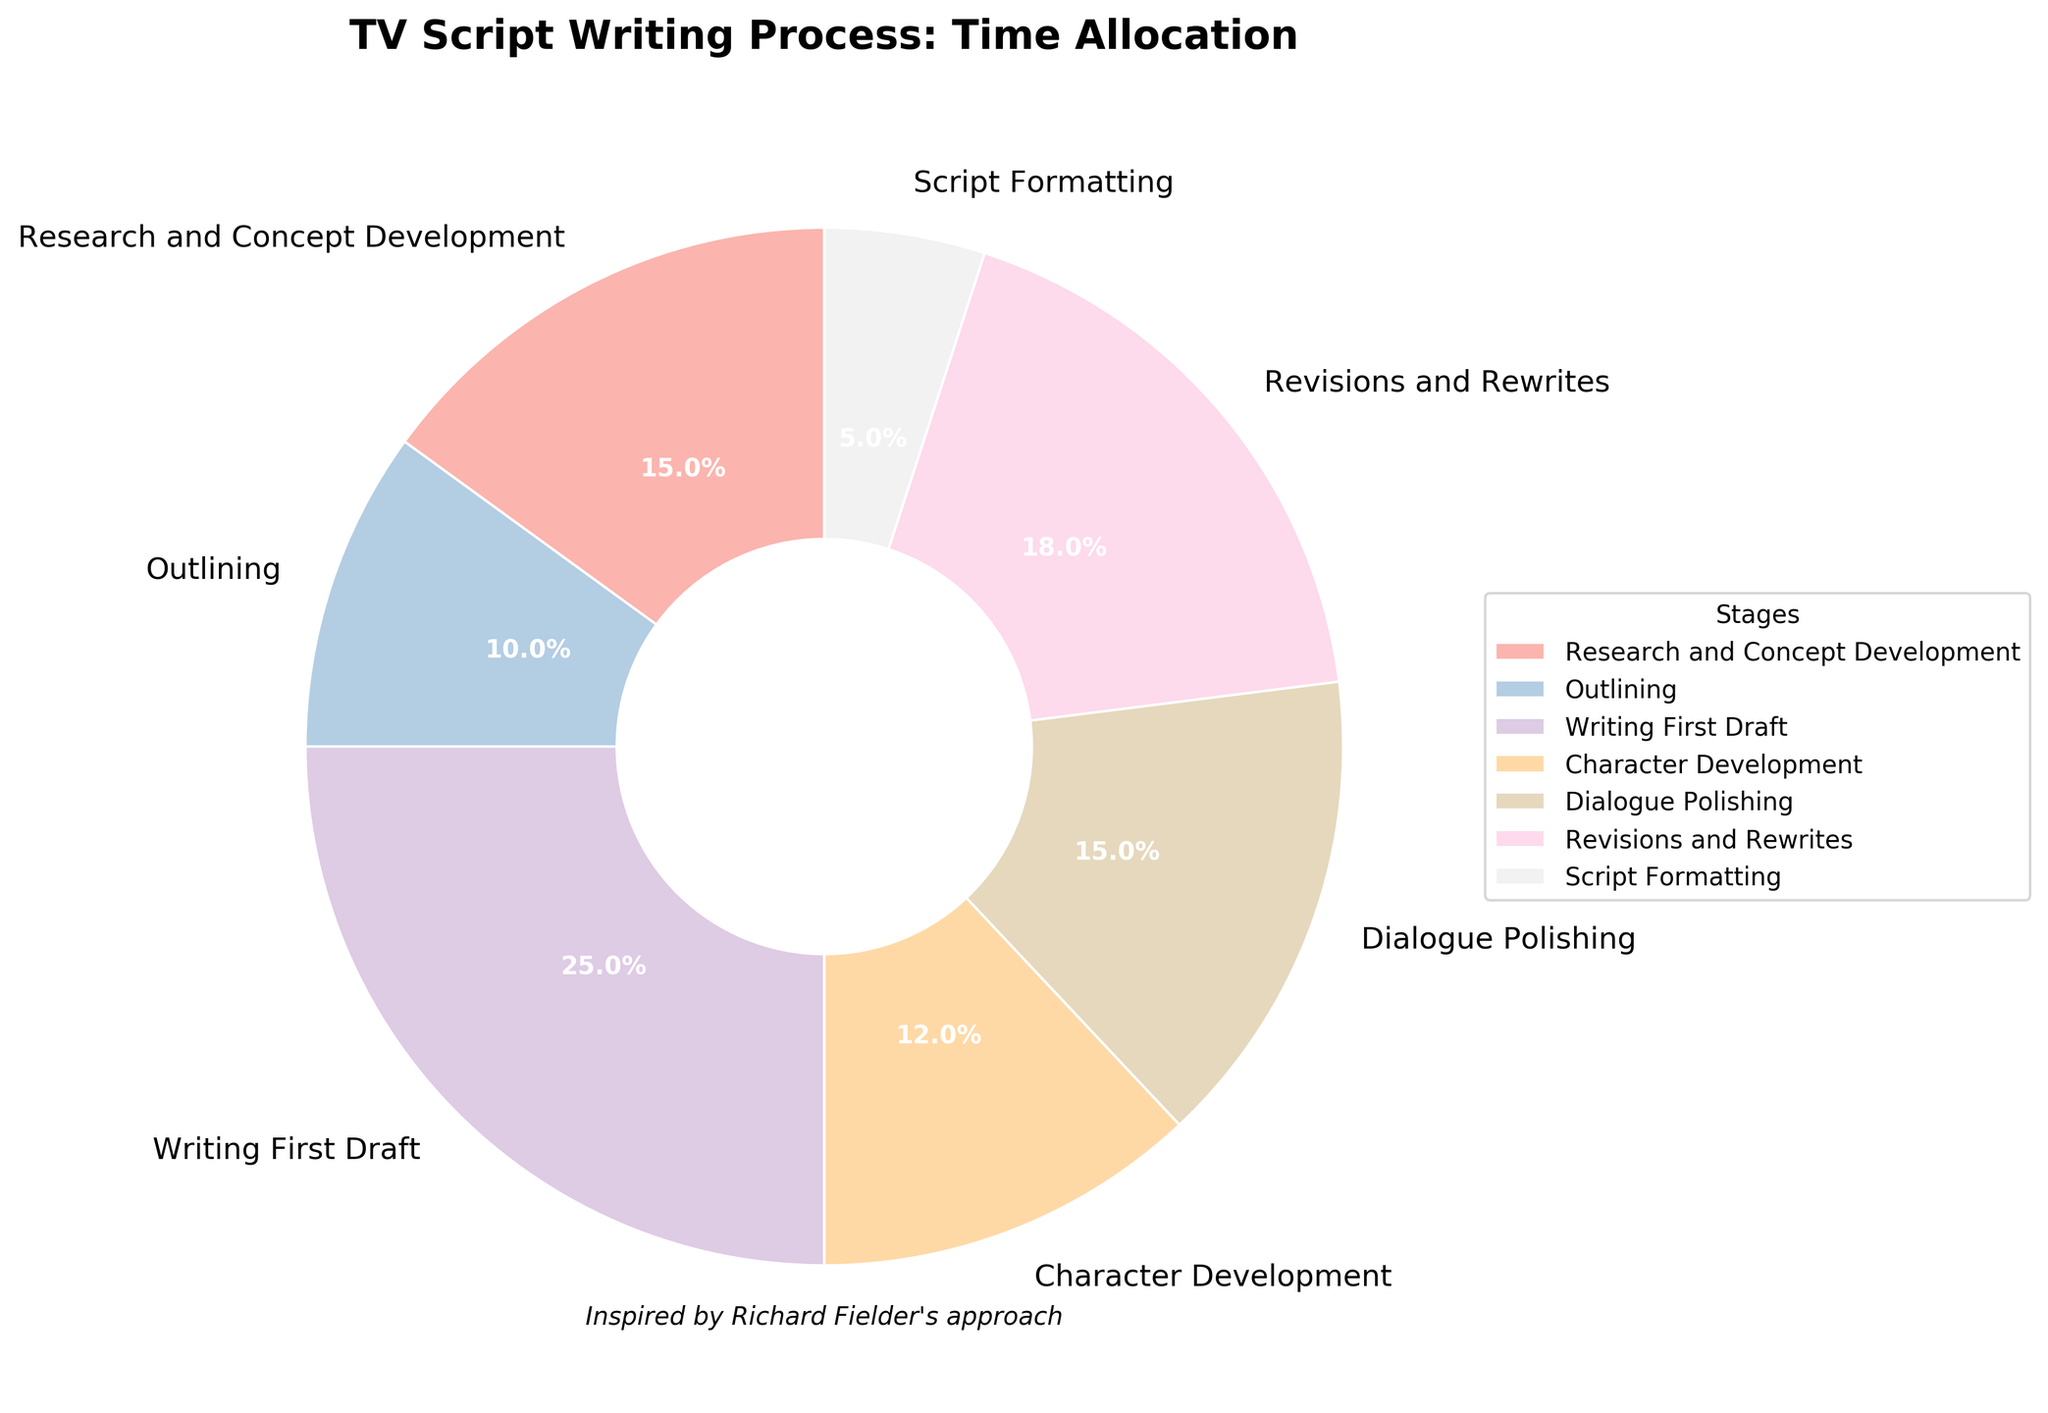What percentage of time is allocated to Dialogue Polishing? The percentage of time allocated to Dialogue Polishing can be directly read from the pie chart segment labeled as “Dialogue Polishing.”
Answer: 15% Which stage takes more time: Research and Concept Development or Character Development? Compare the percentages corresponding to “Research and Concept Development” and “Character Development,” which are 15% and 12% respectively.
Answer: Research and Concept Development What is the sum of the percentages allocated to Writing First Draft and Revisions and Rewrites? Add the percentages corresponding to “Writing First Draft” (25%) and “Revisions and Rewrites” (18%). The total is 25% + 18%.
Answer: 43% How does the time allocated to Script Formatting compare to that allocated to Outlining? Compare the percentages labeled as “Script Formatting” (5%) and “Outlining” (10%).
Answer: Less Which stage is allocated the highest percentage of time? Identify the segment with the largest percentage. “Writing First Draft” has the highest percentage of 25%.
Answer: Writing First Draft If the total time available is 80 hours, how many hours are spent on Revisions and Rewrites? First, find the percentage of time spent on “Revisions and Rewrites,” which is 18%. Then, calculate 18% of 80 hours: 0.18 * 80 = 14.4 hours.
Answer: 14.4 hours What are the stages that have an equal percentage of time allocation? Look for segments with the same percentage value. “Research and Concept Development” and “Dialogue Polishing” both have 15%.
Answer: Research and Concept Development and Dialogue Polishing What is the difference in time allocation between the Character Development and Script Formatting stages? Subtract the percentage of time for “Script Formatting” (5%) from “Character Development” (12%). The difference is 12% - 5%.
Answer: 7% Which stage takes the least amount of time? Identify the segment with the smallest percentage. “Script Formatting” has the lowest percentage of 5%.
Answer: Script Formatting What is the average percentage of time spent on Research and Concept Development, Writing First Draft, and Revisions and Rewrites? Add the percentages for the three stages: 15% + 25% + 18% = 58%. Then, divide by the number of stages, which is 3: 58% / 3 = 19.3%.
Answer: 19.3% 